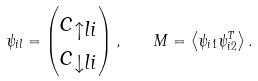Convert formula to latex. <formula><loc_0><loc_0><loc_500><loc_500>\psi _ { i l } = \begin{pmatrix} c _ { \uparrow l i } \\ c _ { \downarrow l i } \end{pmatrix} , \quad M = \left \langle \psi _ { i 1 } \psi _ { i 2 } ^ { T } \right \rangle .</formula> 